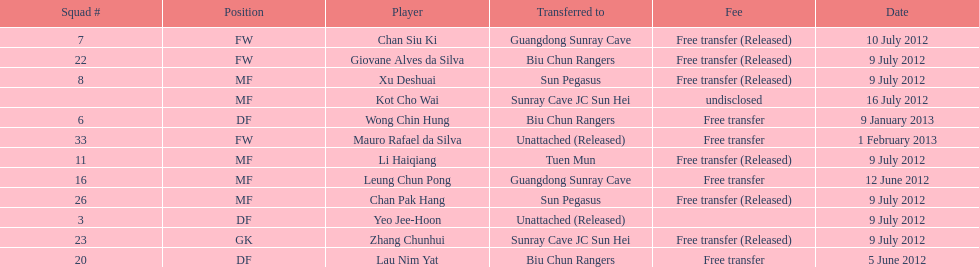Who is the first player listed? Lau Nim Yat. 